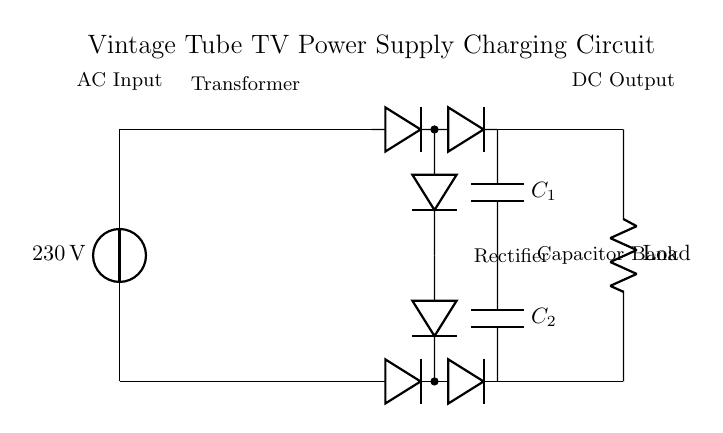What is the input voltage for this circuit? The input voltage is shown directly next to the voltage source symbol in the circuit diagram, which states "230 V".
Answer: 230 V What components are part of the rectifier in this circuit? The rectifier consists of a series of diodes that are represented in two pairs, with an upper and a lower pair aligned vertically. These are responsible for converting AC to DC.
Answer: Diodes How many capacitors are in the capacitor bank? The circuit diagram clearly illustrates two capacitors, labeled C1 and C2, connected in series.
Answer: Two What is the purpose of the transformer in this circuit? The transformer alters the voltage from the AC input to a different level suitable for the next components in the layout. It is labeled "Transformer" in the diagram.
Answer: Voltage conversion What type of output does this circuit provide? The output is indicated as "DC Output" in the diagram, suggesting that the rectification process followed by the capacitor bank delivers a direct current output.
Answer: DC Which component smooths the rectified output? The components labeled C1 and C2 function together as a capacitor bank. Their role is to smooth the fluctuations in the rectified DC output signal.
Answer: Capacitor bank 